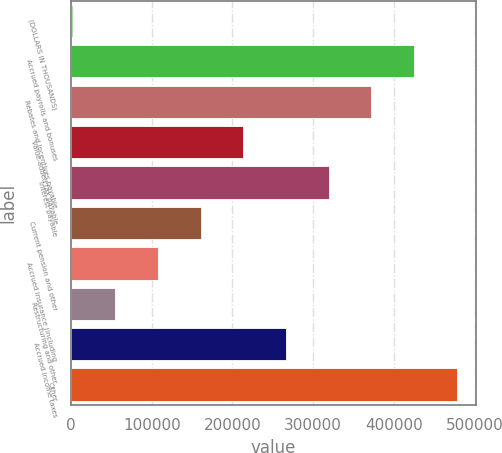<chart> <loc_0><loc_0><loc_500><loc_500><bar_chart><fcel>(DOLLARS IN THOUSANDS)<fcel>Accrued payrolls and bonuses<fcel>Rebates and incentives payable<fcel>Value-added tax payable<fcel>Interest payable<fcel>Current pension and other<fcel>Accrued insurance (including<fcel>Restructuring and other<fcel>Accrued income taxes<fcel>Other<nl><fcel>2018<fcel>424810<fcel>371961<fcel>213414<fcel>319112<fcel>160565<fcel>107716<fcel>54867<fcel>266263<fcel>477659<nl></chart> 